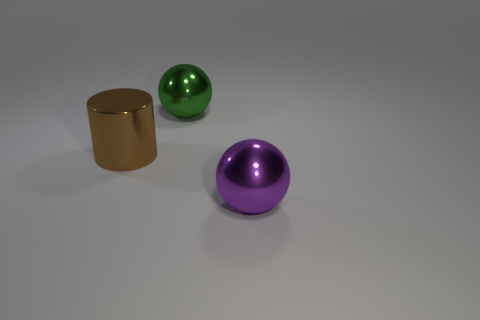What is the size of the purple object that is the same material as the big cylinder?
Your answer should be very brief. Large. What number of other things are the same shape as the big green thing?
Your answer should be compact. 1. Do the big brown object and the large green object have the same material?
Offer a very short reply. Yes. What is the material of the object that is both right of the big brown metal cylinder and in front of the big green thing?
Provide a short and direct response. Metal. What is the color of the sphere that is behind the brown shiny thing?
Make the answer very short. Green. Are there more cylinders in front of the large green thing than small gray matte cylinders?
Give a very brief answer. Yes. What number of other objects are the same size as the green ball?
Provide a succinct answer. 2. How many shiny spheres are in front of the brown shiny cylinder?
Give a very brief answer. 1. Is the number of brown shiny things left of the big green shiny ball the same as the number of large balls that are behind the brown metallic cylinder?
Your answer should be very brief. Yes. What is the size of the green object that is the same shape as the purple metal object?
Keep it short and to the point. Large. 